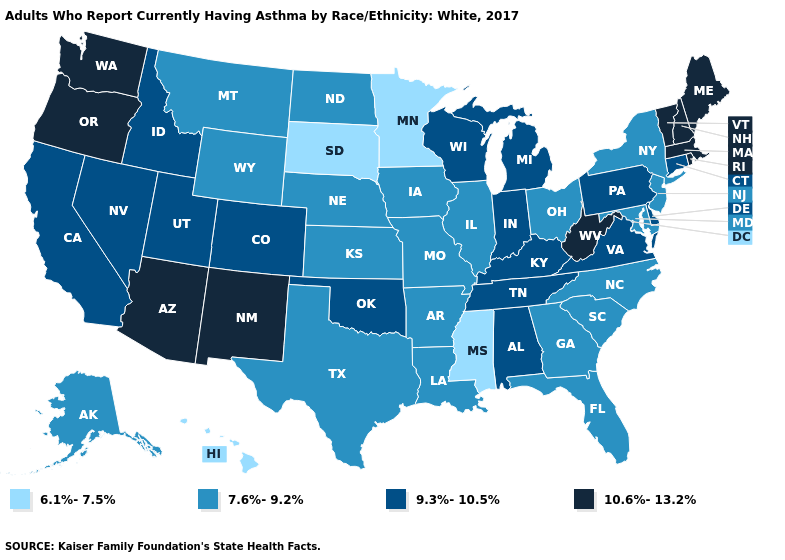Name the states that have a value in the range 7.6%-9.2%?
Short answer required. Alaska, Arkansas, Florida, Georgia, Illinois, Iowa, Kansas, Louisiana, Maryland, Missouri, Montana, Nebraska, New Jersey, New York, North Carolina, North Dakota, Ohio, South Carolina, Texas, Wyoming. How many symbols are there in the legend?
Concise answer only. 4. Among the states that border Arkansas , does Mississippi have the lowest value?
Keep it brief. Yes. Name the states that have a value in the range 9.3%-10.5%?
Be succinct. Alabama, California, Colorado, Connecticut, Delaware, Idaho, Indiana, Kentucky, Michigan, Nevada, Oklahoma, Pennsylvania, Tennessee, Utah, Virginia, Wisconsin. Does Maine have the highest value in the USA?
Concise answer only. Yes. Which states have the lowest value in the Northeast?
Give a very brief answer. New Jersey, New York. What is the lowest value in the USA?
Keep it brief. 6.1%-7.5%. How many symbols are there in the legend?
Answer briefly. 4. Which states have the lowest value in the USA?
Keep it brief. Hawaii, Minnesota, Mississippi, South Dakota. What is the highest value in states that border North Carolina?
Write a very short answer. 9.3%-10.5%. Does Rhode Island have a higher value than Colorado?
Concise answer only. Yes. What is the highest value in the MidWest ?
Short answer required. 9.3%-10.5%. What is the lowest value in states that border Iowa?
Answer briefly. 6.1%-7.5%. Name the states that have a value in the range 9.3%-10.5%?
Give a very brief answer. Alabama, California, Colorado, Connecticut, Delaware, Idaho, Indiana, Kentucky, Michigan, Nevada, Oklahoma, Pennsylvania, Tennessee, Utah, Virginia, Wisconsin. Which states have the lowest value in the West?
Short answer required. Hawaii. 